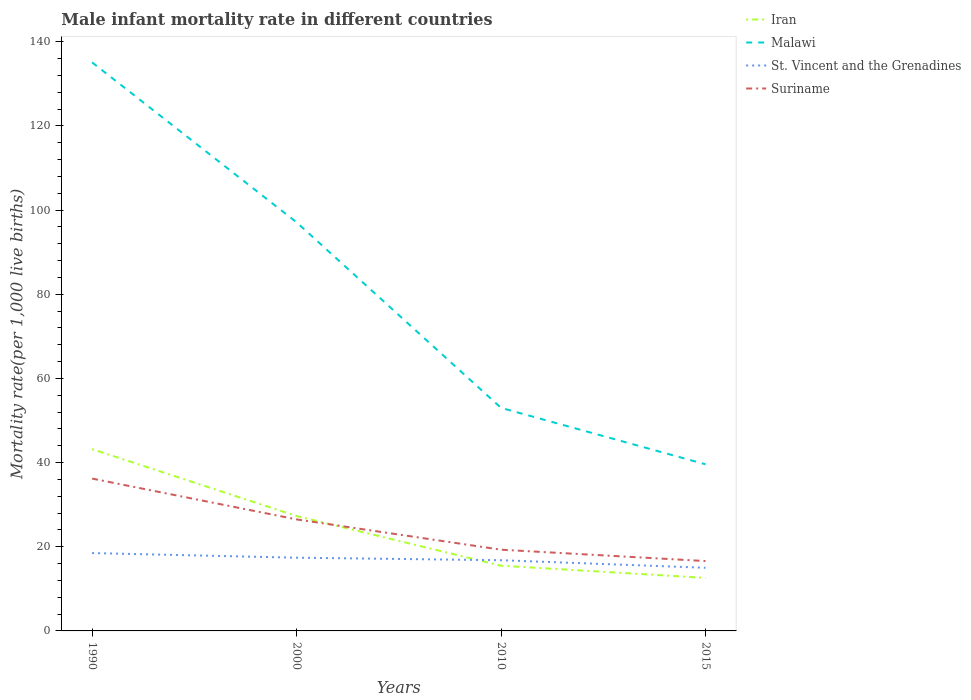How many different coloured lines are there?
Provide a short and direct response. 4. Is the number of lines equal to the number of legend labels?
Your response must be concise. Yes. Across all years, what is the maximum male infant mortality rate in Iran?
Keep it short and to the point. 12.6. In which year was the male infant mortality rate in Suriname maximum?
Offer a terse response. 2015. What is the total male infant mortality rate in Suriname in the graph?
Ensure brevity in your answer.  7.2. What is the difference between the highest and the second highest male infant mortality rate in Iran?
Your response must be concise. 30.6. What is the difference between the highest and the lowest male infant mortality rate in Iran?
Your answer should be compact. 2. Is the male infant mortality rate in Iran strictly greater than the male infant mortality rate in St. Vincent and the Grenadines over the years?
Ensure brevity in your answer.  No. How many lines are there?
Your answer should be compact. 4. How many years are there in the graph?
Ensure brevity in your answer.  4. What is the difference between two consecutive major ticks on the Y-axis?
Provide a succinct answer. 20. Are the values on the major ticks of Y-axis written in scientific E-notation?
Give a very brief answer. No. Does the graph contain any zero values?
Give a very brief answer. No. Where does the legend appear in the graph?
Keep it short and to the point. Top right. How many legend labels are there?
Offer a very short reply. 4. How are the legend labels stacked?
Make the answer very short. Vertical. What is the title of the graph?
Keep it short and to the point. Male infant mortality rate in different countries. Does "Zimbabwe" appear as one of the legend labels in the graph?
Your response must be concise. No. What is the label or title of the X-axis?
Provide a succinct answer. Years. What is the label or title of the Y-axis?
Your answer should be very brief. Mortality rate(per 1,0 live births). What is the Mortality rate(per 1,000 live births) in Iran in 1990?
Your answer should be compact. 43.2. What is the Mortality rate(per 1,000 live births) in Malawi in 1990?
Give a very brief answer. 135.1. What is the Mortality rate(per 1,000 live births) of St. Vincent and the Grenadines in 1990?
Your answer should be compact. 18.5. What is the Mortality rate(per 1,000 live births) of Suriname in 1990?
Your response must be concise. 36.2. What is the Mortality rate(per 1,000 live births) of Iran in 2000?
Your response must be concise. 27.3. What is the Mortality rate(per 1,000 live births) of Malawi in 2000?
Keep it short and to the point. 97.1. What is the Mortality rate(per 1,000 live births) in St. Vincent and the Grenadines in 2000?
Provide a succinct answer. 17.4. What is the Mortality rate(per 1,000 live births) of Suriname in 2000?
Provide a short and direct response. 26.5. What is the Mortality rate(per 1,000 live births) of Suriname in 2010?
Provide a succinct answer. 19.3. What is the Mortality rate(per 1,000 live births) in Iran in 2015?
Your answer should be compact. 12.6. What is the Mortality rate(per 1,000 live births) of Malawi in 2015?
Ensure brevity in your answer.  39.6. What is the Mortality rate(per 1,000 live births) of St. Vincent and the Grenadines in 2015?
Offer a very short reply. 15. What is the Mortality rate(per 1,000 live births) of Suriname in 2015?
Give a very brief answer. 16.6. Across all years, what is the maximum Mortality rate(per 1,000 live births) in Iran?
Provide a short and direct response. 43.2. Across all years, what is the maximum Mortality rate(per 1,000 live births) in Malawi?
Your answer should be very brief. 135.1. Across all years, what is the maximum Mortality rate(per 1,000 live births) of St. Vincent and the Grenadines?
Make the answer very short. 18.5. Across all years, what is the maximum Mortality rate(per 1,000 live births) of Suriname?
Offer a terse response. 36.2. Across all years, what is the minimum Mortality rate(per 1,000 live births) in Iran?
Your answer should be compact. 12.6. Across all years, what is the minimum Mortality rate(per 1,000 live births) in Malawi?
Offer a very short reply. 39.6. Across all years, what is the minimum Mortality rate(per 1,000 live births) of Suriname?
Offer a terse response. 16.6. What is the total Mortality rate(per 1,000 live births) in Iran in the graph?
Offer a terse response. 98.6. What is the total Mortality rate(per 1,000 live births) in Malawi in the graph?
Give a very brief answer. 324.8. What is the total Mortality rate(per 1,000 live births) in St. Vincent and the Grenadines in the graph?
Your answer should be compact. 67.7. What is the total Mortality rate(per 1,000 live births) of Suriname in the graph?
Give a very brief answer. 98.6. What is the difference between the Mortality rate(per 1,000 live births) of Iran in 1990 and that in 2000?
Your response must be concise. 15.9. What is the difference between the Mortality rate(per 1,000 live births) of St. Vincent and the Grenadines in 1990 and that in 2000?
Keep it short and to the point. 1.1. What is the difference between the Mortality rate(per 1,000 live births) of Suriname in 1990 and that in 2000?
Provide a succinct answer. 9.7. What is the difference between the Mortality rate(per 1,000 live births) in Iran in 1990 and that in 2010?
Provide a short and direct response. 27.7. What is the difference between the Mortality rate(per 1,000 live births) of Malawi in 1990 and that in 2010?
Your answer should be compact. 82.1. What is the difference between the Mortality rate(per 1,000 live births) in St. Vincent and the Grenadines in 1990 and that in 2010?
Ensure brevity in your answer.  1.7. What is the difference between the Mortality rate(per 1,000 live births) in Iran in 1990 and that in 2015?
Your answer should be compact. 30.6. What is the difference between the Mortality rate(per 1,000 live births) in Malawi in 1990 and that in 2015?
Provide a succinct answer. 95.5. What is the difference between the Mortality rate(per 1,000 live births) in Suriname in 1990 and that in 2015?
Offer a very short reply. 19.6. What is the difference between the Mortality rate(per 1,000 live births) of Malawi in 2000 and that in 2010?
Keep it short and to the point. 44.1. What is the difference between the Mortality rate(per 1,000 live births) in Suriname in 2000 and that in 2010?
Provide a short and direct response. 7.2. What is the difference between the Mortality rate(per 1,000 live births) in Iran in 2000 and that in 2015?
Your response must be concise. 14.7. What is the difference between the Mortality rate(per 1,000 live births) of Malawi in 2000 and that in 2015?
Offer a very short reply. 57.5. What is the difference between the Mortality rate(per 1,000 live births) of Malawi in 2010 and that in 2015?
Your response must be concise. 13.4. What is the difference between the Mortality rate(per 1,000 live births) in Iran in 1990 and the Mortality rate(per 1,000 live births) in Malawi in 2000?
Keep it short and to the point. -53.9. What is the difference between the Mortality rate(per 1,000 live births) of Iran in 1990 and the Mortality rate(per 1,000 live births) of St. Vincent and the Grenadines in 2000?
Give a very brief answer. 25.8. What is the difference between the Mortality rate(per 1,000 live births) of Iran in 1990 and the Mortality rate(per 1,000 live births) of Suriname in 2000?
Give a very brief answer. 16.7. What is the difference between the Mortality rate(per 1,000 live births) in Malawi in 1990 and the Mortality rate(per 1,000 live births) in St. Vincent and the Grenadines in 2000?
Your answer should be very brief. 117.7. What is the difference between the Mortality rate(per 1,000 live births) in Malawi in 1990 and the Mortality rate(per 1,000 live births) in Suriname in 2000?
Ensure brevity in your answer.  108.6. What is the difference between the Mortality rate(per 1,000 live births) of Iran in 1990 and the Mortality rate(per 1,000 live births) of St. Vincent and the Grenadines in 2010?
Provide a succinct answer. 26.4. What is the difference between the Mortality rate(per 1,000 live births) of Iran in 1990 and the Mortality rate(per 1,000 live births) of Suriname in 2010?
Offer a terse response. 23.9. What is the difference between the Mortality rate(per 1,000 live births) in Malawi in 1990 and the Mortality rate(per 1,000 live births) in St. Vincent and the Grenadines in 2010?
Offer a terse response. 118.3. What is the difference between the Mortality rate(per 1,000 live births) in Malawi in 1990 and the Mortality rate(per 1,000 live births) in Suriname in 2010?
Your response must be concise. 115.8. What is the difference between the Mortality rate(per 1,000 live births) in St. Vincent and the Grenadines in 1990 and the Mortality rate(per 1,000 live births) in Suriname in 2010?
Your answer should be compact. -0.8. What is the difference between the Mortality rate(per 1,000 live births) in Iran in 1990 and the Mortality rate(per 1,000 live births) in St. Vincent and the Grenadines in 2015?
Your answer should be compact. 28.2. What is the difference between the Mortality rate(per 1,000 live births) of Iran in 1990 and the Mortality rate(per 1,000 live births) of Suriname in 2015?
Make the answer very short. 26.6. What is the difference between the Mortality rate(per 1,000 live births) in Malawi in 1990 and the Mortality rate(per 1,000 live births) in St. Vincent and the Grenadines in 2015?
Ensure brevity in your answer.  120.1. What is the difference between the Mortality rate(per 1,000 live births) in Malawi in 1990 and the Mortality rate(per 1,000 live births) in Suriname in 2015?
Your answer should be very brief. 118.5. What is the difference between the Mortality rate(per 1,000 live births) of Iran in 2000 and the Mortality rate(per 1,000 live births) of Malawi in 2010?
Provide a short and direct response. -25.7. What is the difference between the Mortality rate(per 1,000 live births) of Iran in 2000 and the Mortality rate(per 1,000 live births) of St. Vincent and the Grenadines in 2010?
Your answer should be very brief. 10.5. What is the difference between the Mortality rate(per 1,000 live births) in Iran in 2000 and the Mortality rate(per 1,000 live births) in Suriname in 2010?
Provide a short and direct response. 8. What is the difference between the Mortality rate(per 1,000 live births) in Malawi in 2000 and the Mortality rate(per 1,000 live births) in St. Vincent and the Grenadines in 2010?
Keep it short and to the point. 80.3. What is the difference between the Mortality rate(per 1,000 live births) of Malawi in 2000 and the Mortality rate(per 1,000 live births) of Suriname in 2010?
Make the answer very short. 77.8. What is the difference between the Mortality rate(per 1,000 live births) in Iran in 2000 and the Mortality rate(per 1,000 live births) in St. Vincent and the Grenadines in 2015?
Ensure brevity in your answer.  12.3. What is the difference between the Mortality rate(per 1,000 live births) in Malawi in 2000 and the Mortality rate(per 1,000 live births) in St. Vincent and the Grenadines in 2015?
Give a very brief answer. 82.1. What is the difference between the Mortality rate(per 1,000 live births) of Malawi in 2000 and the Mortality rate(per 1,000 live births) of Suriname in 2015?
Provide a succinct answer. 80.5. What is the difference between the Mortality rate(per 1,000 live births) of St. Vincent and the Grenadines in 2000 and the Mortality rate(per 1,000 live births) of Suriname in 2015?
Give a very brief answer. 0.8. What is the difference between the Mortality rate(per 1,000 live births) of Iran in 2010 and the Mortality rate(per 1,000 live births) of Malawi in 2015?
Your response must be concise. -24.1. What is the difference between the Mortality rate(per 1,000 live births) in Malawi in 2010 and the Mortality rate(per 1,000 live births) in St. Vincent and the Grenadines in 2015?
Your answer should be very brief. 38. What is the difference between the Mortality rate(per 1,000 live births) of Malawi in 2010 and the Mortality rate(per 1,000 live births) of Suriname in 2015?
Your response must be concise. 36.4. What is the difference between the Mortality rate(per 1,000 live births) in St. Vincent and the Grenadines in 2010 and the Mortality rate(per 1,000 live births) in Suriname in 2015?
Your answer should be compact. 0.2. What is the average Mortality rate(per 1,000 live births) in Iran per year?
Provide a succinct answer. 24.65. What is the average Mortality rate(per 1,000 live births) of Malawi per year?
Make the answer very short. 81.2. What is the average Mortality rate(per 1,000 live births) of St. Vincent and the Grenadines per year?
Ensure brevity in your answer.  16.93. What is the average Mortality rate(per 1,000 live births) in Suriname per year?
Your response must be concise. 24.65. In the year 1990, what is the difference between the Mortality rate(per 1,000 live births) of Iran and Mortality rate(per 1,000 live births) of Malawi?
Keep it short and to the point. -91.9. In the year 1990, what is the difference between the Mortality rate(per 1,000 live births) in Iran and Mortality rate(per 1,000 live births) in St. Vincent and the Grenadines?
Offer a very short reply. 24.7. In the year 1990, what is the difference between the Mortality rate(per 1,000 live births) in Iran and Mortality rate(per 1,000 live births) in Suriname?
Offer a terse response. 7. In the year 1990, what is the difference between the Mortality rate(per 1,000 live births) of Malawi and Mortality rate(per 1,000 live births) of St. Vincent and the Grenadines?
Make the answer very short. 116.6. In the year 1990, what is the difference between the Mortality rate(per 1,000 live births) of Malawi and Mortality rate(per 1,000 live births) of Suriname?
Your response must be concise. 98.9. In the year 1990, what is the difference between the Mortality rate(per 1,000 live births) in St. Vincent and the Grenadines and Mortality rate(per 1,000 live births) in Suriname?
Keep it short and to the point. -17.7. In the year 2000, what is the difference between the Mortality rate(per 1,000 live births) in Iran and Mortality rate(per 1,000 live births) in Malawi?
Make the answer very short. -69.8. In the year 2000, what is the difference between the Mortality rate(per 1,000 live births) of Iran and Mortality rate(per 1,000 live births) of Suriname?
Ensure brevity in your answer.  0.8. In the year 2000, what is the difference between the Mortality rate(per 1,000 live births) of Malawi and Mortality rate(per 1,000 live births) of St. Vincent and the Grenadines?
Offer a terse response. 79.7. In the year 2000, what is the difference between the Mortality rate(per 1,000 live births) in Malawi and Mortality rate(per 1,000 live births) in Suriname?
Offer a terse response. 70.6. In the year 2010, what is the difference between the Mortality rate(per 1,000 live births) of Iran and Mortality rate(per 1,000 live births) of Malawi?
Give a very brief answer. -37.5. In the year 2010, what is the difference between the Mortality rate(per 1,000 live births) of Malawi and Mortality rate(per 1,000 live births) of St. Vincent and the Grenadines?
Your response must be concise. 36.2. In the year 2010, what is the difference between the Mortality rate(per 1,000 live births) of Malawi and Mortality rate(per 1,000 live births) of Suriname?
Make the answer very short. 33.7. In the year 2015, what is the difference between the Mortality rate(per 1,000 live births) of Iran and Mortality rate(per 1,000 live births) of St. Vincent and the Grenadines?
Offer a very short reply. -2.4. In the year 2015, what is the difference between the Mortality rate(per 1,000 live births) in Iran and Mortality rate(per 1,000 live births) in Suriname?
Keep it short and to the point. -4. In the year 2015, what is the difference between the Mortality rate(per 1,000 live births) in Malawi and Mortality rate(per 1,000 live births) in St. Vincent and the Grenadines?
Provide a short and direct response. 24.6. In the year 2015, what is the difference between the Mortality rate(per 1,000 live births) of Malawi and Mortality rate(per 1,000 live births) of Suriname?
Ensure brevity in your answer.  23. In the year 2015, what is the difference between the Mortality rate(per 1,000 live births) in St. Vincent and the Grenadines and Mortality rate(per 1,000 live births) in Suriname?
Provide a short and direct response. -1.6. What is the ratio of the Mortality rate(per 1,000 live births) of Iran in 1990 to that in 2000?
Provide a succinct answer. 1.58. What is the ratio of the Mortality rate(per 1,000 live births) of Malawi in 1990 to that in 2000?
Your response must be concise. 1.39. What is the ratio of the Mortality rate(per 1,000 live births) in St. Vincent and the Grenadines in 1990 to that in 2000?
Your answer should be compact. 1.06. What is the ratio of the Mortality rate(per 1,000 live births) of Suriname in 1990 to that in 2000?
Ensure brevity in your answer.  1.37. What is the ratio of the Mortality rate(per 1,000 live births) in Iran in 1990 to that in 2010?
Ensure brevity in your answer.  2.79. What is the ratio of the Mortality rate(per 1,000 live births) of Malawi in 1990 to that in 2010?
Your response must be concise. 2.55. What is the ratio of the Mortality rate(per 1,000 live births) of St. Vincent and the Grenadines in 1990 to that in 2010?
Provide a short and direct response. 1.1. What is the ratio of the Mortality rate(per 1,000 live births) of Suriname in 1990 to that in 2010?
Offer a very short reply. 1.88. What is the ratio of the Mortality rate(per 1,000 live births) in Iran in 1990 to that in 2015?
Your answer should be very brief. 3.43. What is the ratio of the Mortality rate(per 1,000 live births) of Malawi in 1990 to that in 2015?
Your answer should be very brief. 3.41. What is the ratio of the Mortality rate(per 1,000 live births) in St. Vincent and the Grenadines in 1990 to that in 2015?
Make the answer very short. 1.23. What is the ratio of the Mortality rate(per 1,000 live births) of Suriname in 1990 to that in 2015?
Keep it short and to the point. 2.18. What is the ratio of the Mortality rate(per 1,000 live births) in Iran in 2000 to that in 2010?
Your answer should be compact. 1.76. What is the ratio of the Mortality rate(per 1,000 live births) of Malawi in 2000 to that in 2010?
Keep it short and to the point. 1.83. What is the ratio of the Mortality rate(per 1,000 live births) of St. Vincent and the Grenadines in 2000 to that in 2010?
Provide a succinct answer. 1.04. What is the ratio of the Mortality rate(per 1,000 live births) of Suriname in 2000 to that in 2010?
Your answer should be very brief. 1.37. What is the ratio of the Mortality rate(per 1,000 live births) in Iran in 2000 to that in 2015?
Offer a terse response. 2.17. What is the ratio of the Mortality rate(per 1,000 live births) of Malawi in 2000 to that in 2015?
Your answer should be compact. 2.45. What is the ratio of the Mortality rate(per 1,000 live births) in St. Vincent and the Grenadines in 2000 to that in 2015?
Ensure brevity in your answer.  1.16. What is the ratio of the Mortality rate(per 1,000 live births) of Suriname in 2000 to that in 2015?
Your answer should be very brief. 1.6. What is the ratio of the Mortality rate(per 1,000 live births) of Iran in 2010 to that in 2015?
Provide a short and direct response. 1.23. What is the ratio of the Mortality rate(per 1,000 live births) of Malawi in 2010 to that in 2015?
Ensure brevity in your answer.  1.34. What is the ratio of the Mortality rate(per 1,000 live births) of St. Vincent and the Grenadines in 2010 to that in 2015?
Provide a succinct answer. 1.12. What is the ratio of the Mortality rate(per 1,000 live births) in Suriname in 2010 to that in 2015?
Keep it short and to the point. 1.16. What is the difference between the highest and the lowest Mortality rate(per 1,000 live births) in Iran?
Keep it short and to the point. 30.6. What is the difference between the highest and the lowest Mortality rate(per 1,000 live births) in Malawi?
Make the answer very short. 95.5. What is the difference between the highest and the lowest Mortality rate(per 1,000 live births) of St. Vincent and the Grenadines?
Your answer should be very brief. 3.5. What is the difference between the highest and the lowest Mortality rate(per 1,000 live births) in Suriname?
Your response must be concise. 19.6. 